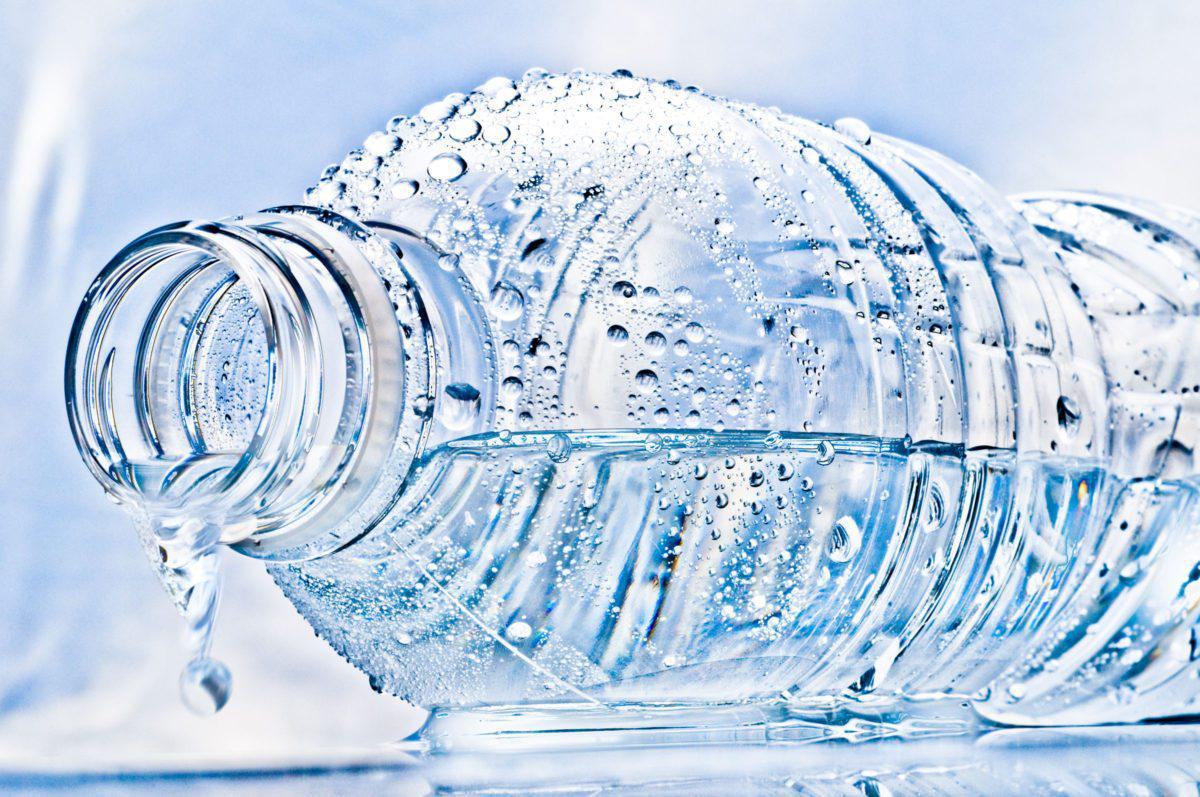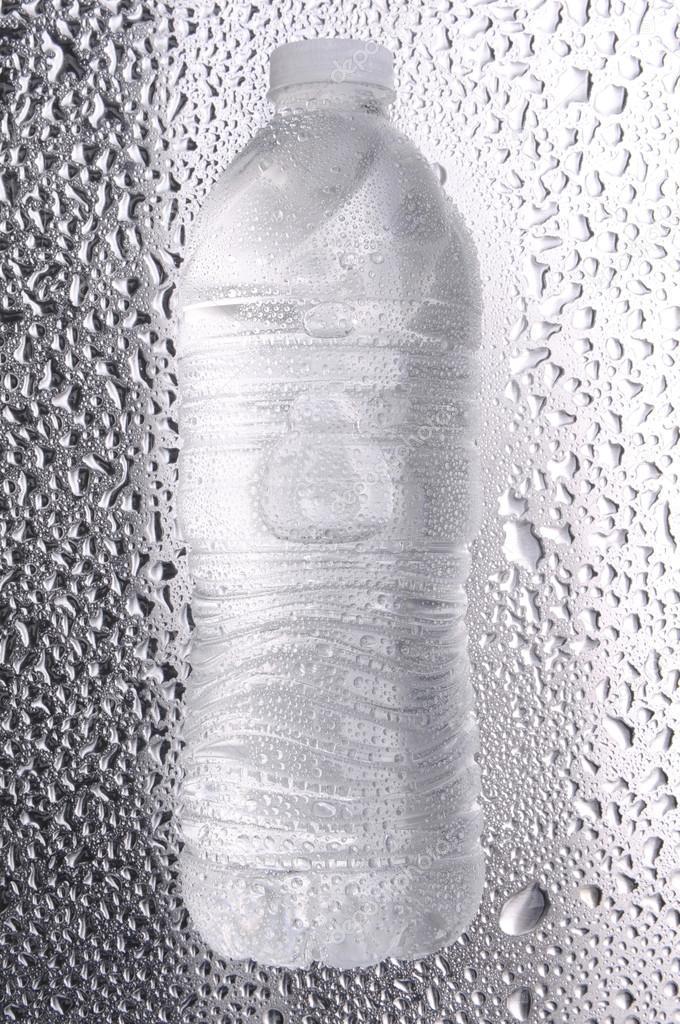The first image is the image on the left, the second image is the image on the right. Evaluate the accuracy of this statement regarding the images: "An image shows multiple water bottles surrounded by ice cubes.". Is it true? Answer yes or no. No. The first image is the image on the left, the second image is the image on the right. For the images shown, is this caption "At least three of the bottles in one of the images has a blue cap." true? Answer yes or no. No. 